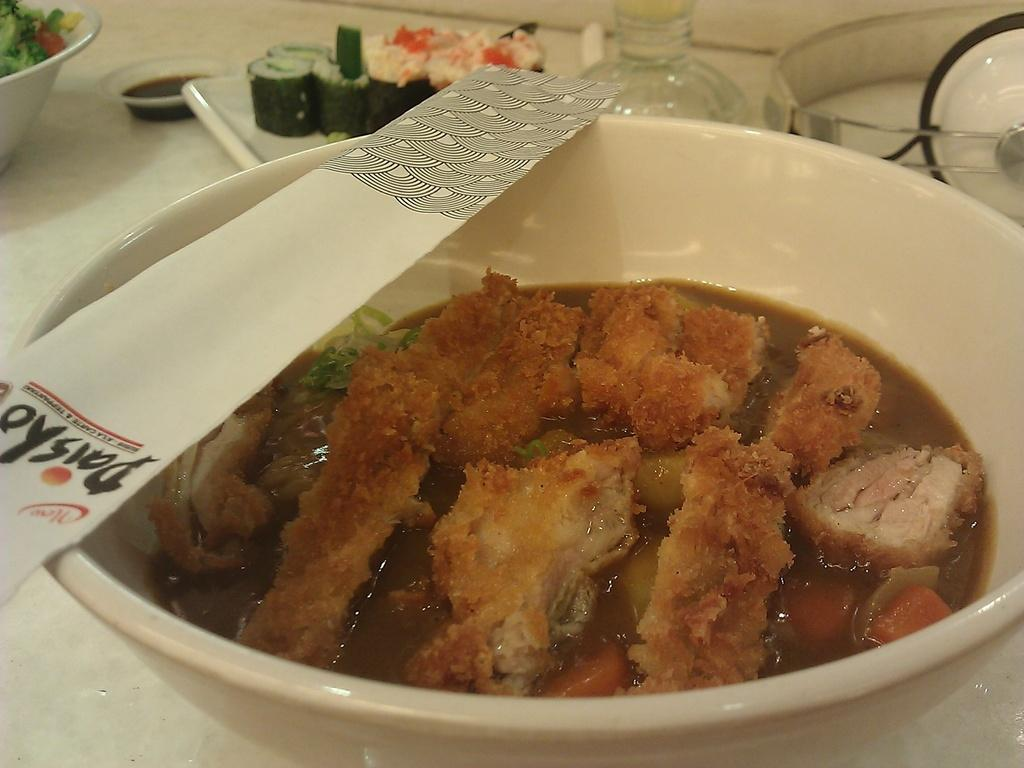What type of furniture is visible in the image? There is a table in the image. What is in the bowl that is visible on the table? There is a bowl containing food in the image. What specific type of food can be seen in the bowl? Sushi is present in the image. What other types of food are visible in the image? There are bottled items and a salad in the image. How is the food arranged on the table? There is a plate placed on the table in the image. Can you tell me how many dogs are sitting on the table in the image? There are no dogs present in the image; it only features a table, a bowl, sushi, bottled items, a salad, and a plate. 